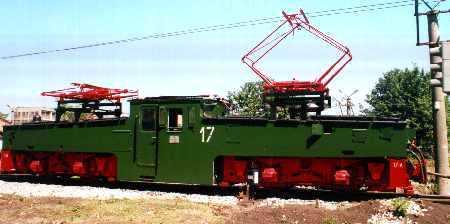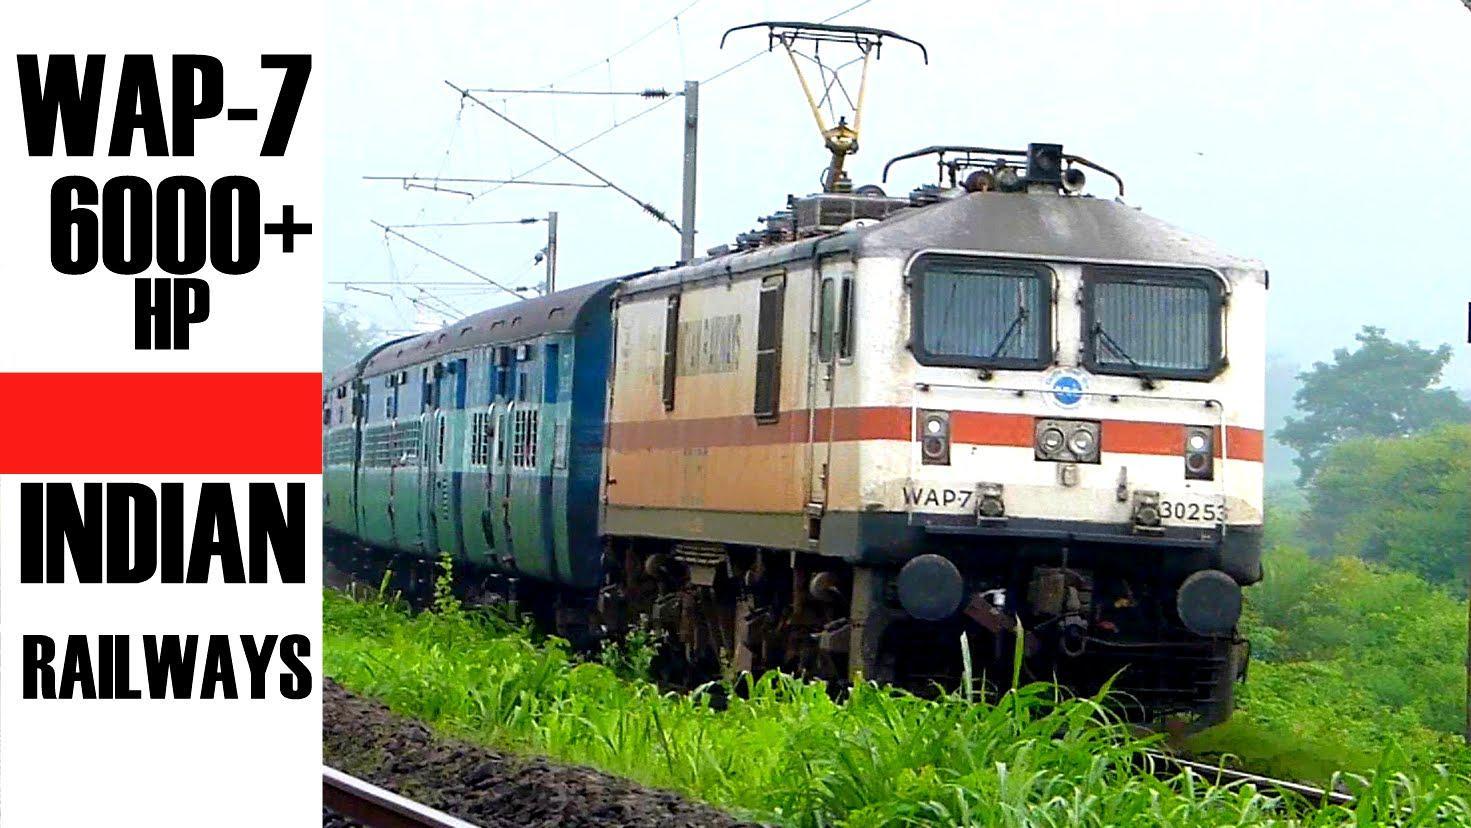The first image is the image on the left, the second image is the image on the right. Considering the images on both sides, is "Both trains are primarily green and moving toward the right." valid? Answer yes or no. No. The first image is the image on the left, the second image is the image on the right. Assess this claim about the two images: "All trains are greenish in color and heading rightward at an angle.". Correct or not? Answer yes or no. No. 